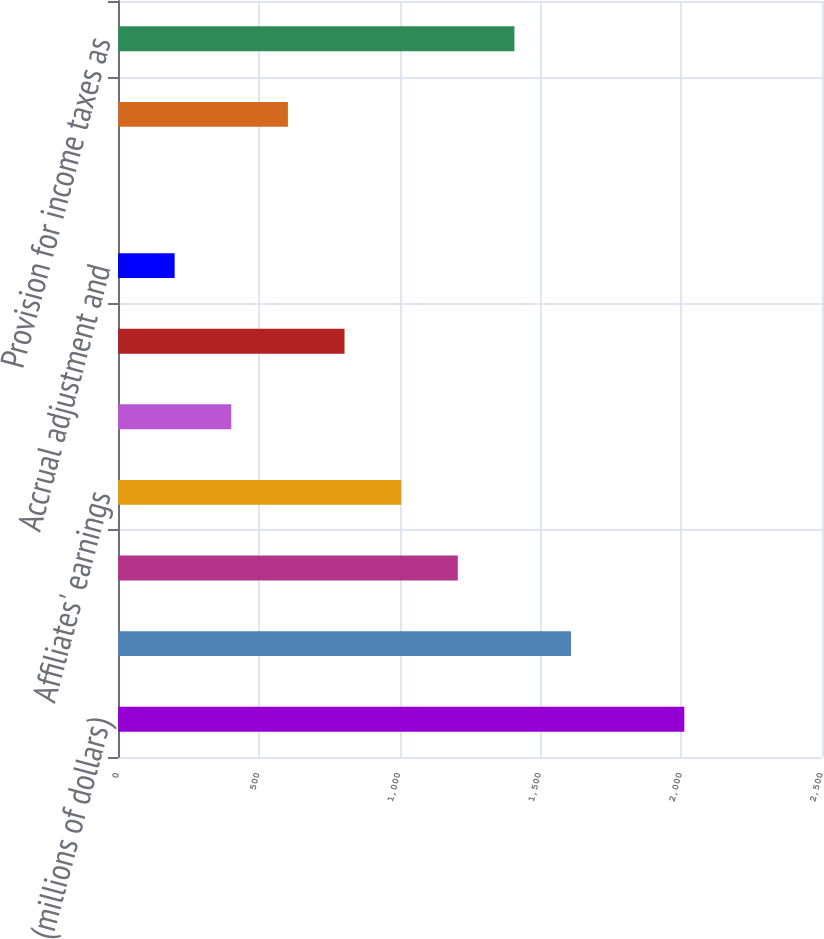Convert chart to OTSL. <chart><loc_0><loc_0><loc_500><loc_500><bar_chart><fcel>(millions of dollars)<fcel>Income taxes at US statutory<fcel>Income from non-US sources<fcel>Affiliates' earnings<fcel>State taxes net of federal<fcel>Business tax credits<fcel>Accrual adjustment and<fcel>Medicare Part D<fcel>Non-temporary differences and<fcel>Provision for income taxes as<nl><fcel>2011<fcel>1608.82<fcel>1206.64<fcel>1005.55<fcel>402.28<fcel>804.46<fcel>201.19<fcel>0.1<fcel>603.37<fcel>1407.73<nl></chart> 